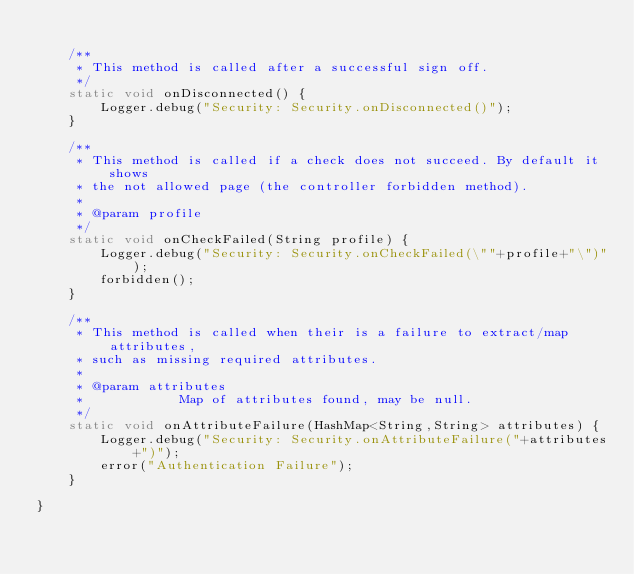<code> <loc_0><loc_0><loc_500><loc_500><_Java_>
	/**
	 * This method is called after a successful sign off.
	 */
	static void onDisconnected() {
		Logger.debug("Security: Security.onDisconnected()");
	}

	/**
	 * This method is called if a check does not succeed. By default it shows
	 * the not allowed page (the controller forbidden method).
	 * 
	 * @param profile
	 */
	static void onCheckFailed(String profile) {
		Logger.debug("Security: Security.onCheckFailed(\""+profile+"\")");
		forbidden();
	}
	
	/**
	 * This method is called when their is a failure to extract/map attributes,
	 * such as missing required attributes.
	 * 
	 * @param attributes
	 *            Map of attributes found, may be null.
	 */
	static void onAttributeFailure(HashMap<String,String> attributes) {
		Logger.debug("Security: Security.onAttributeFailure("+attributes+")");
		error("Authentication Failure");
	}

}
</code> 